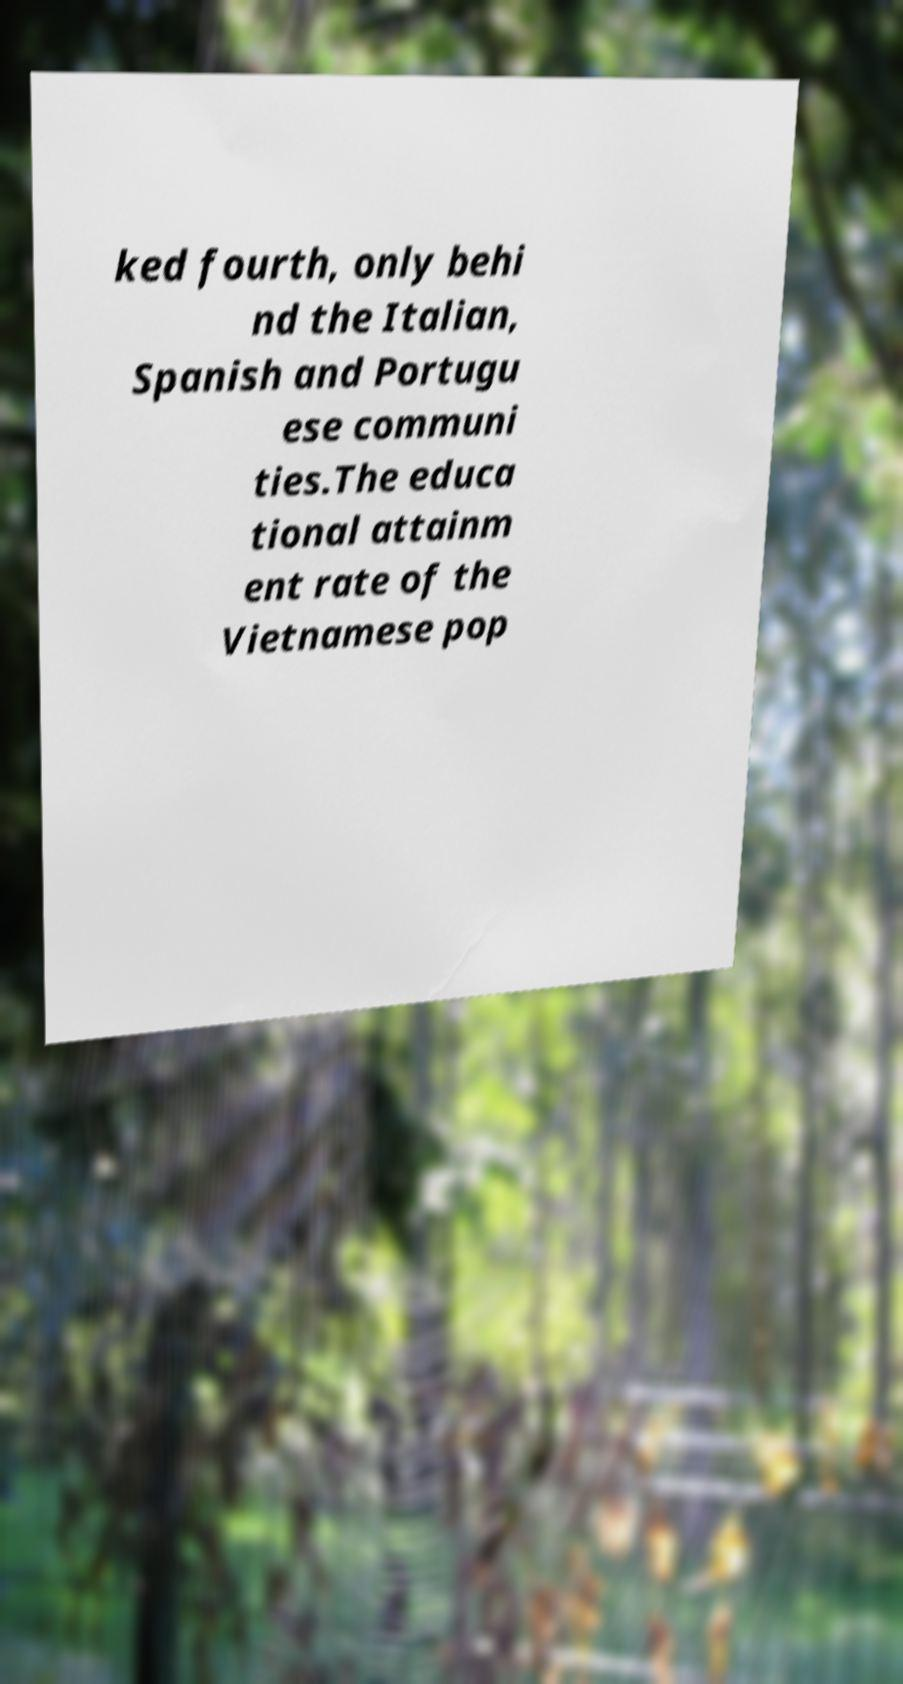What messages or text are displayed in this image? I need them in a readable, typed format. ked fourth, only behi nd the Italian, Spanish and Portugu ese communi ties.The educa tional attainm ent rate of the Vietnamese pop 